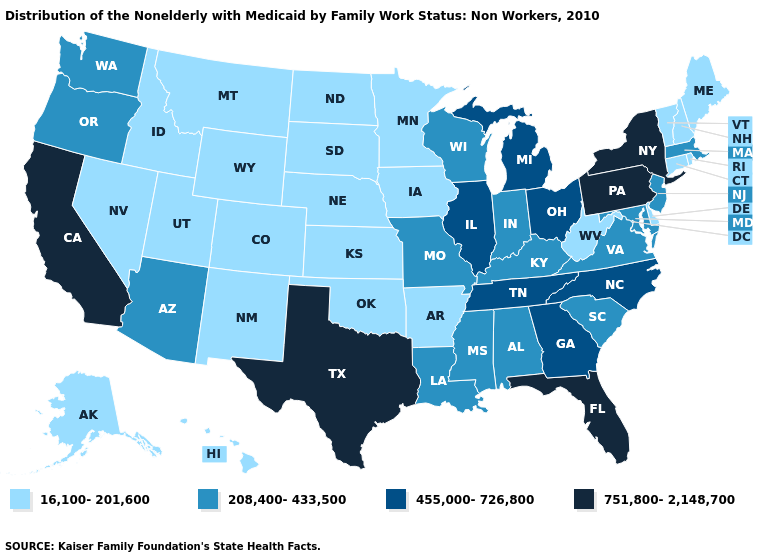What is the lowest value in states that border Rhode Island?
Answer briefly. 16,100-201,600. Does Idaho have the highest value in the West?
Be succinct. No. Does the map have missing data?
Answer briefly. No. What is the value of New York?
Give a very brief answer. 751,800-2,148,700. Does Missouri have a higher value than Kentucky?
Quick response, please. No. Which states hav the highest value in the South?
Answer briefly. Florida, Texas. Among the states that border Iowa , which have the highest value?
Quick response, please. Illinois. Does Nevada have the lowest value in the West?
Short answer required. Yes. Name the states that have a value in the range 751,800-2,148,700?
Concise answer only. California, Florida, New York, Pennsylvania, Texas. Name the states that have a value in the range 208,400-433,500?
Write a very short answer. Alabama, Arizona, Indiana, Kentucky, Louisiana, Maryland, Massachusetts, Mississippi, Missouri, New Jersey, Oregon, South Carolina, Virginia, Washington, Wisconsin. What is the lowest value in the USA?
Answer briefly. 16,100-201,600. What is the lowest value in states that border Montana?
Quick response, please. 16,100-201,600. What is the value of New York?
Quick response, please. 751,800-2,148,700. Does California have the highest value in the West?
Short answer required. Yes. What is the value of Montana?
Be succinct. 16,100-201,600. 